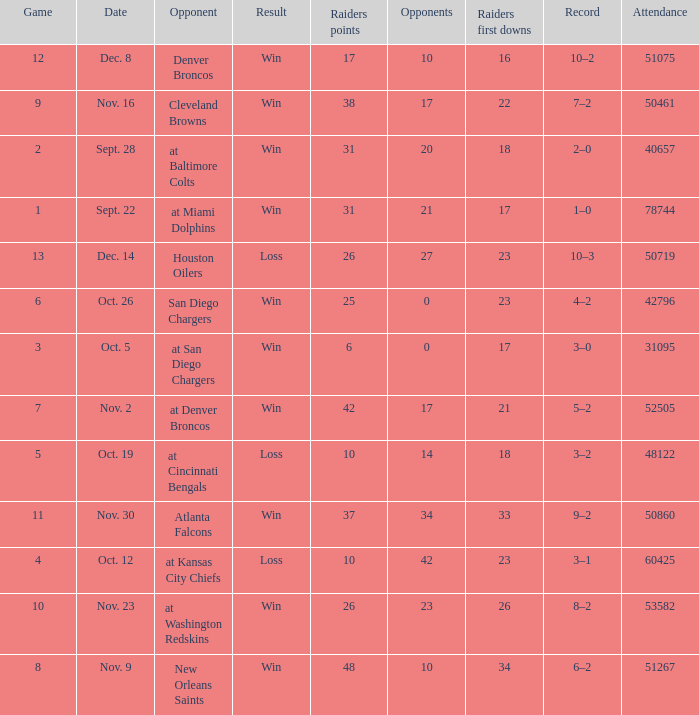How many opponents played 1 game with a result win? 21.0. 